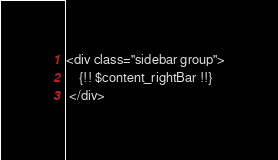<code> <loc_0><loc_0><loc_500><loc_500><_PHP_><div class="sidebar group">
	{!! $content_rightBar !!}
 </div></code> 